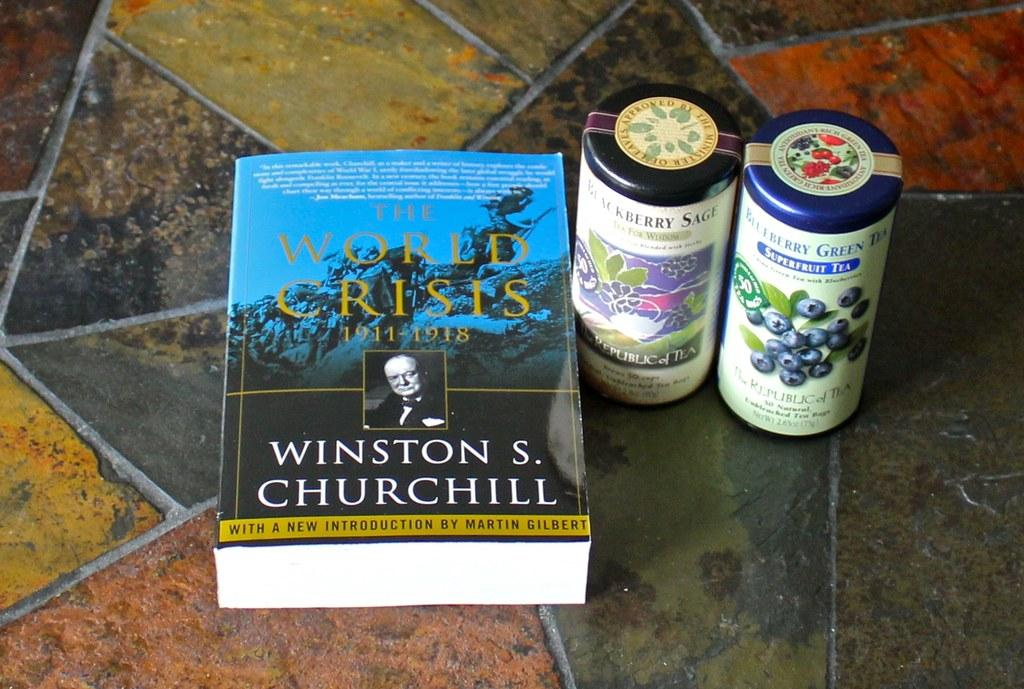<image>
Describe the image concisely. A book by Winston Churchill sits on a stone floor next to two cans of tea 